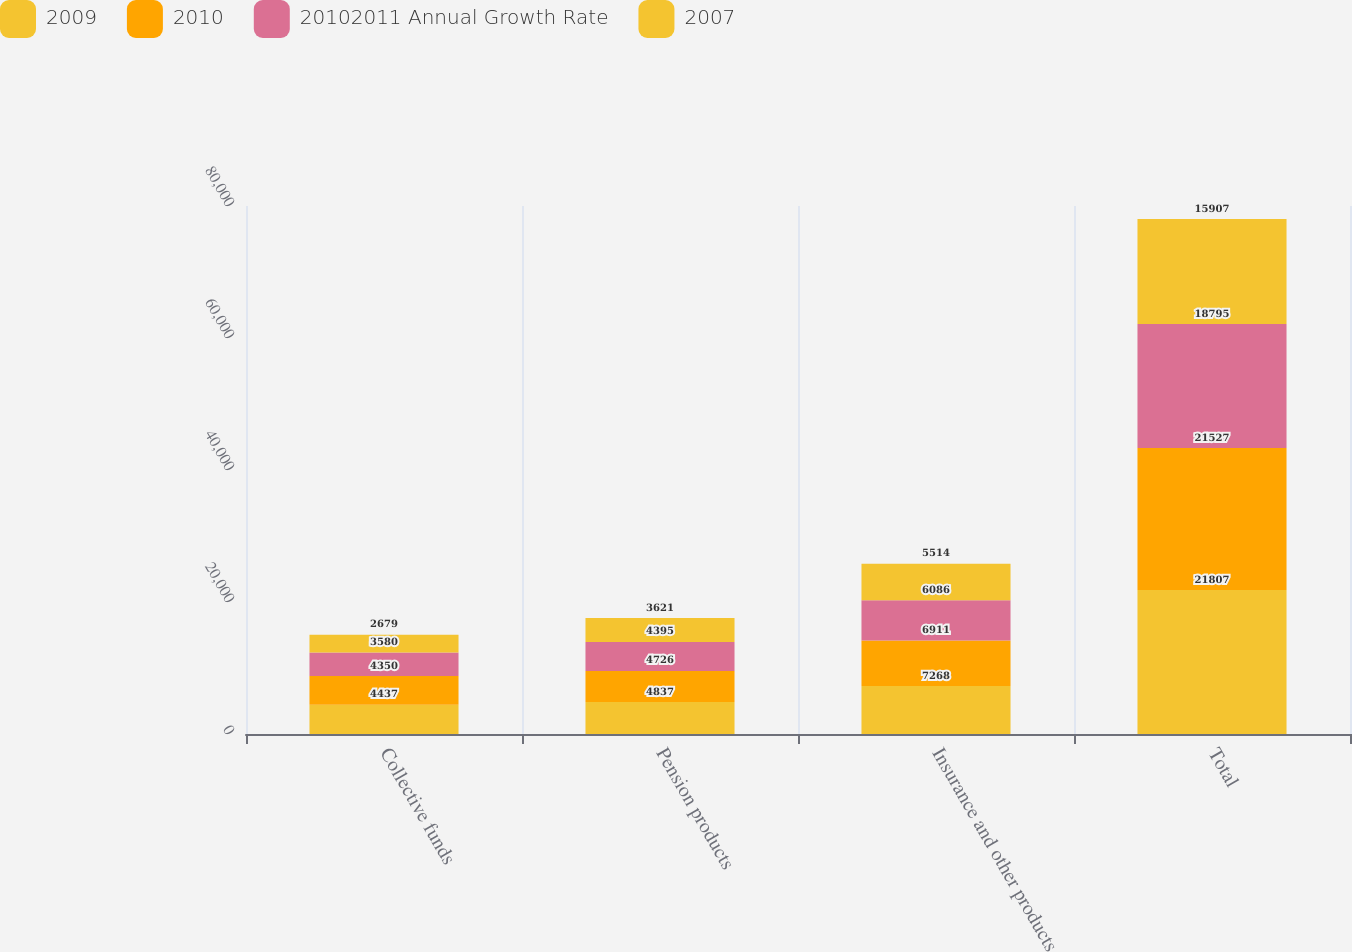<chart> <loc_0><loc_0><loc_500><loc_500><stacked_bar_chart><ecel><fcel>Collective funds<fcel>Pension products<fcel>Insurance and other products<fcel>Total<nl><fcel>2009<fcel>4437<fcel>4837<fcel>7268<fcel>21807<nl><fcel>2010<fcel>4350<fcel>4726<fcel>6911<fcel>21527<nl><fcel>20102011 Annual Growth Rate<fcel>3580<fcel>4395<fcel>6086<fcel>18795<nl><fcel>2007<fcel>2679<fcel>3621<fcel>5514<fcel>15907<nl></chart> 